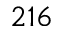<formula> <loc_0><loc_0><loc_500><loc_500>2 1 6</formula> 